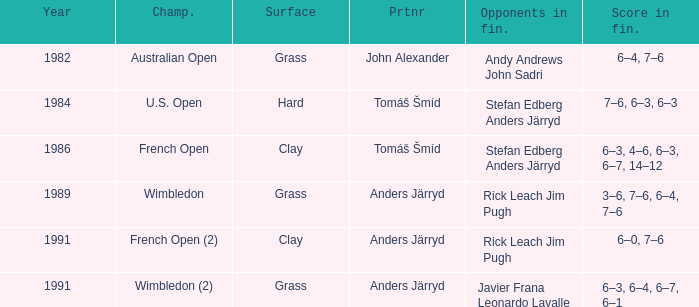What was the final score in 1986? 6–3, 4–6, 6–3, 6–7, 14–12. 